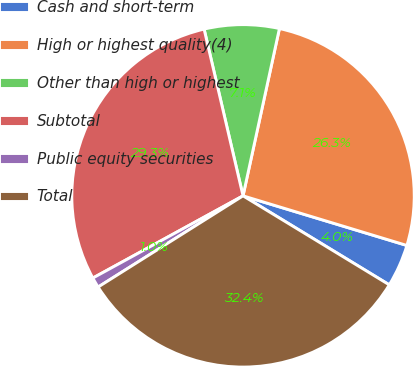Convert chart to OTSL. <chart><loc_0><loc_0><loc_500><loc_500><pie_chart><fcel>Cash and short-term<fcel>High or highest quality(4)<fcel>Other than high or highest<fcel>Subtotal<fcel>Public equity securities<fcel>Total<nl><fcel>4.02%<fcel>26.27%<fcel>7.06%<fcel>29.32%<fcel>0.97%<fcel>32.36%<nl></chart> 